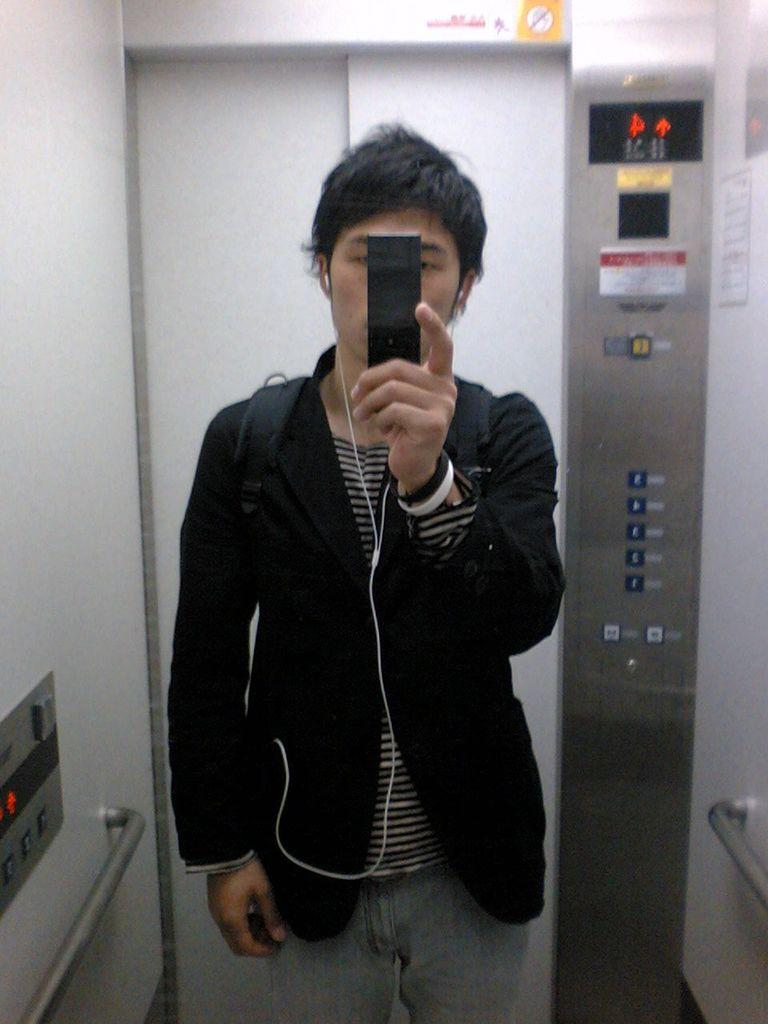What is the man in the image doing? The man is standing in a lift. What is the man holding in his hand? The man is holding an object in his hand. What can be seen in the background of the image? There is a metal rod and buttons in the background of the image, along with other objects. What type of zipper is visible on the man's elbow in the image? There is no zipper visible on the man's elbow in the image, as he is not wearing any clothing that would expose his elbow. 